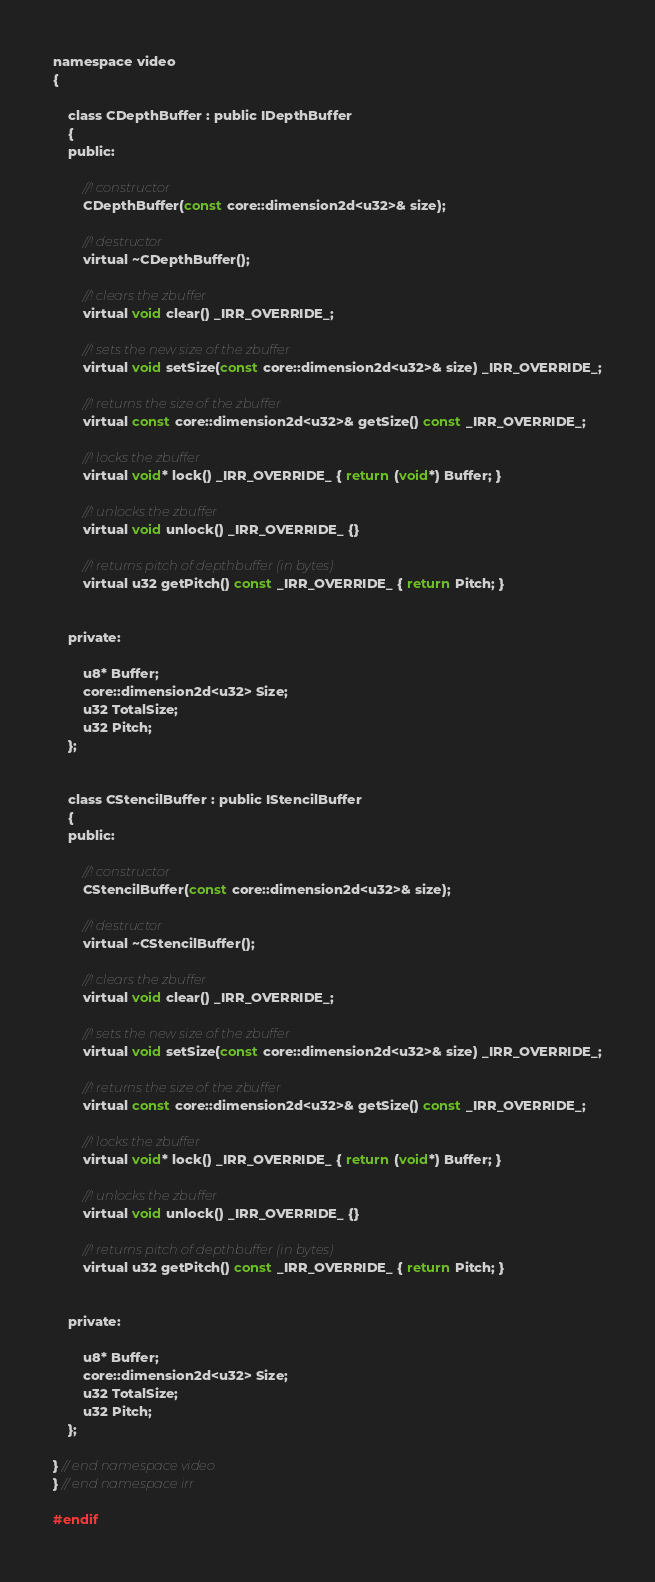<code> <loc_0><loc_0><loc_500><loc_500><_C_>namespace video
{

	class CDepthBuffer : public IDepthBuffer
	{
	public:

		//! constructor
		CDepthBuffer(const core::dimension2d<u32>& size);

		//! destructor
		virtual ~CDepthBuffer();

		//! clears the zbuffer
		virtual void clear() _IRR_OVERRIDE_;

		//! sets the new size of the zbuffer
		virtual void setSize(const core::dimension2d<u32>& size) _IRR_OVERRIDE_;

		//! returns the size of the zbuffer
		virtual const core::dimension2d<u32>& getSize() const _IRR_OVERRIDE_;

		//! locks the zbuffer
		virtual void* lock() _IRR_OVERRIDE_ { return (void*) Buffer; }

		//! unlocks the zbuffer
		virtual void unlock() _IRR_OVERRIDE_ {}

		//! returns pitch of depthbuffer (in bytes)
		virtual u32 getPitch() const _IRR_OVERRIDE_ { return Pitch; }


	private:

		u8* Buffer;
		core::dimension2d<u32> Size;
		u32 TotalSize;
		u32 Pitch;
	};


	class CStencilBuffer : public IStencilBuffer
	{
	public:

		//! constructor
		CStencilBuffer(const core::dimension2d<u32>& size);

		//! destructor
		virtual ~CStencilBuffer();

		//! clears the zbuffer
		virtual void clear() _IRR_OVERRIDE_;

		//! sets the new size of the zbuffer
		virtual void setSize(const core::dimension2d<u32>& size) _IRR_OVERRIDE_;

		//! returns the size of the zbuffer
		virtual const core::dimension2d<u32>& getSize() const _IRR_OVERRIDE_;

		//! locks the zbuffer
		virtual void* lock() _IRR_OVERRIDE_ { return (void*) Buffer; }

		//! unlocks the zbuffer
		virtual void unlock() _IRR_OVERRIDE_ {}

		//! returns pitch of depthbuffer (in bytes)
		virtual u32 getPitch() const _IRR_OVERRIDE_ { return Pitch; }


	private:

		u8* Buffer;
		core::dimension2d<u32> Size;
		u32 TotalSize;
		u32 Pitch;
	};

} // end namespace video
} // end namespace irr

#endif

</code> 